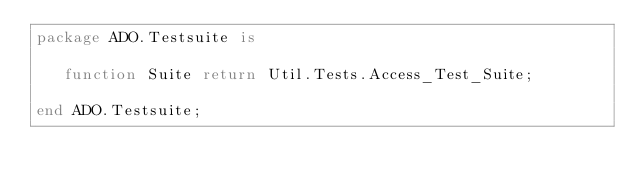Convert code to text. <code><loc_0><loc_0><loc_500><loc_500><_Ada_>package ADO.Testsuite is

   function Suite return Util.Tests.Access_Test_Suite;

end ADO.Testsuite;
</code> 